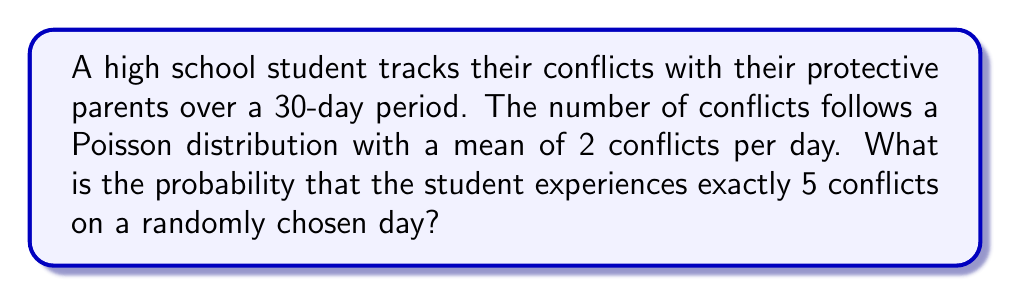Can you answer this question? Let's approach this step-by-step:

1) The Poisson distribution is given by the formula:

   $$P(X = k) = \frac{e^{-\lambda}\lambda^k}{k!}$$

   Where:
   - $\lambda$ is the average number of events in the interval
   - $k$ is the number of events we're calculating the probability for
   - $e$ is Euler's number (approximately 2.71828)

2) In this case:
   - $\lambda = 2$ (average of 2 conflicts per day)
   - $k = 5$ (we're calculating the probability of exactly 5 conflicts)

3) Let's substitute these values into the formula:

   $$P(X = 5) = \frac{e^{-2}2^5}{5!}$$

4) Now, let's calculate step by step:
   
   $$P(X = 5) = \frac{e^{-2} \cdot 32}{120}$$

5) $e^{-2} \approx 0.1353$

6) Substituting this value:

   $$P(X = 5) \approx \frac{0.1353 \cdot 32}{120} \approx 0.0361$$

7) Converting to a percentage:

   $$0.0361 \cdot 100\% \approx 3.61\%$$
Answer: 3.61% 